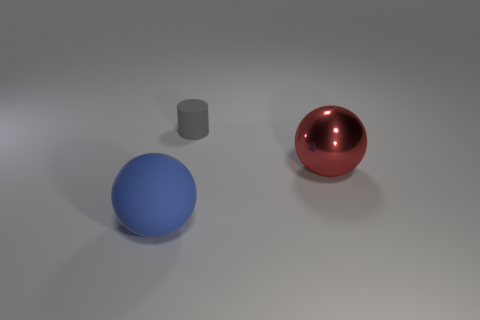Subtract all brown balls. Subtract all purple cubes. How many balls are left? 2 Add 3 gray cylinders. How many objects exist? 6 Subtract all balls. How many objects are left? 1 Subtract 0 purple spheres. How many objects are left? 3 Subtract all big gray rubber balls. Subtract all large red objects. How many objects are left? 2 Add 1 large spheres. How many large spheres are left? 3 Add 2 tiny blue cylinders. How many tiny blue cylinders exist? 2 